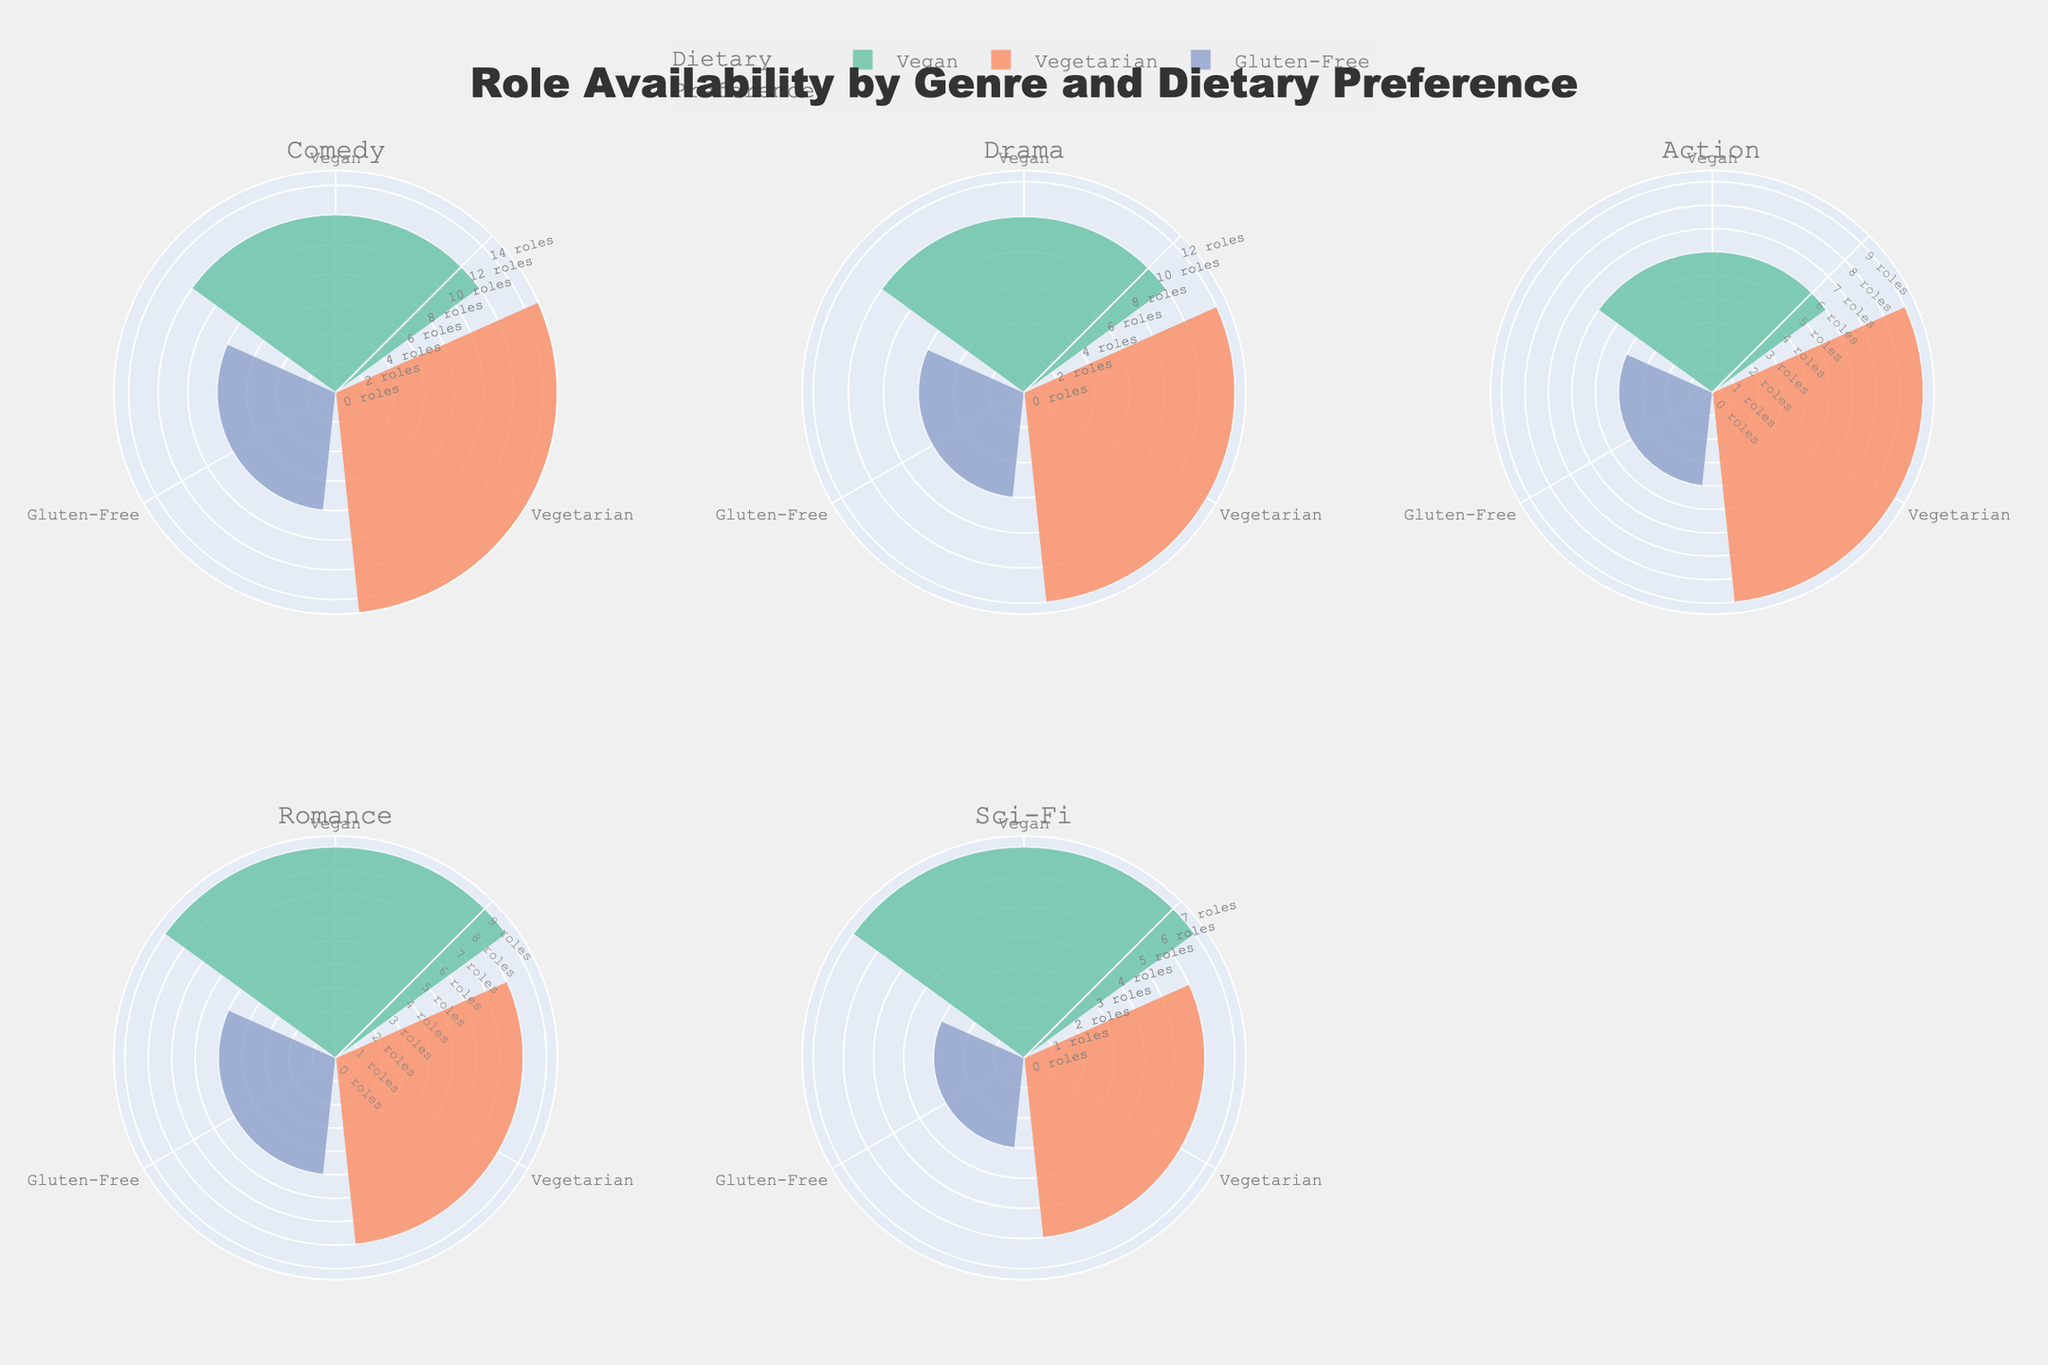what is the title of the figure? The title is usually at the top of the figure. In this case, it reads "Role Availability by Genre and Dietary Preference".
Answer: Role Availability by Genre and Dietary Preference What are the colors representing each dietary preference in the figure? The colors representing dietary preferences are defined in the figure legend. "Vegan" is green, "Vegetarian" is orange, and "Gluten-Free" is purple.
Answer: Vegan: green, Vegetarian: orange, Gluten-Free: purple Which genre has the highest number of roles for Vegetarians? By looking at each sub-plot for the genre and comparing the bar length for "Vegetarian" roles, "Comedy" has the highest bar at 15.
Answer: Comedy In the Drama genre, how many more Vegetarian roles are there compared to Gluten-Free roles? Find the lengths of the bars for Drama, Vegetarian (12) and Gluten-Free (6), then subtract 6 from 12.
Answer: 6 How many total roles are available in the Sci-Fi genre for all dietary preferences combined? Add all the role counts for Sci-Fi: Vegan (7), Vegetarian (6), Gluten-Free (3). The total is 7 + 6 + 3 = 16 roles.
Answer: 16 Which dietary preference has the least number of roles in the Action genre? By comparing the bars for Vegan, Vegetarian, and Gluten-Free in the Action genre, Gluten-Free has the shortest bar at 4.
Answer: Gluten-Free Does any genre have an equal number of roles for Vegan and Gluten-Free dietary preferences? Look at each sub-plot and compare the bar lengths of Vegan and Gluten-Free within each genre. None of the genres have equal numbers for these preferences.
Answer: No Is the number of Vegan roles in Romance greater than the number of Vegetarian roles in Sci-Fi? Compare the bar lengths: Romance, Vegan (9) and Sci-Fi, Vegetarian (6). Since 9 is greater than 6, the answer is yes.
Answer: Yes 